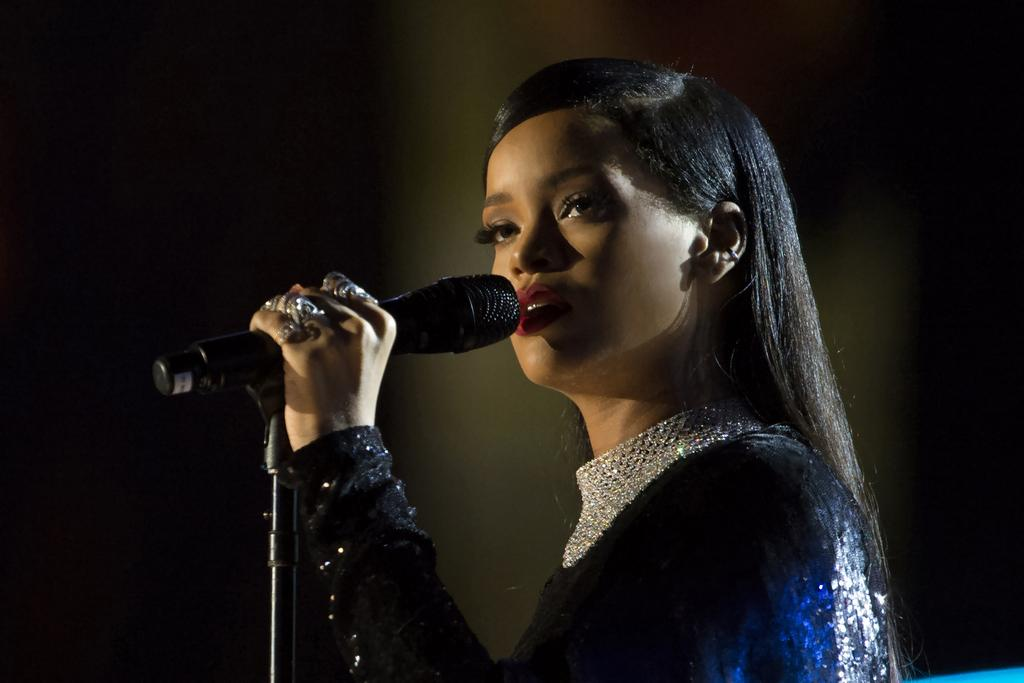Who or what is the main subject in the image? There is a person in the image. Can you describe the person's attire? The person is wearing colorful clothes. What is the person holding in the image? The person is holding a mic with his hands. What type of decision can be seen being made by the rabbits in the image? There are no rabbits present in the image, so no decision can be observed. 